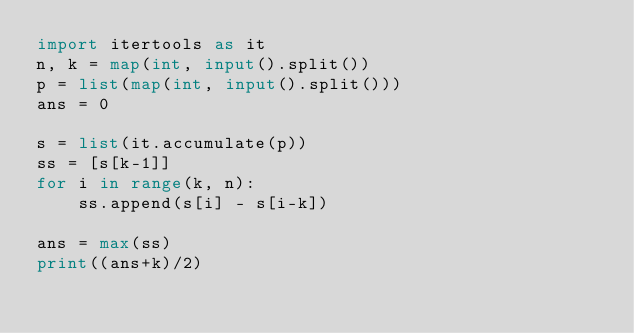Convert code to text. <code><loc_0><loc_0><loc_500><loc_500><_Python_>import itertools as it
n, k = map(int, input().split())
p = list(map(int, input().split()))
ans = 0

s = list(it.accumulate(p))
ss = [s[k-1]]
for i in range(k, n):
    ss.append(s[i] - s[i-k])
    
ans = max(ss)
print((ans+k)/2)</code> 